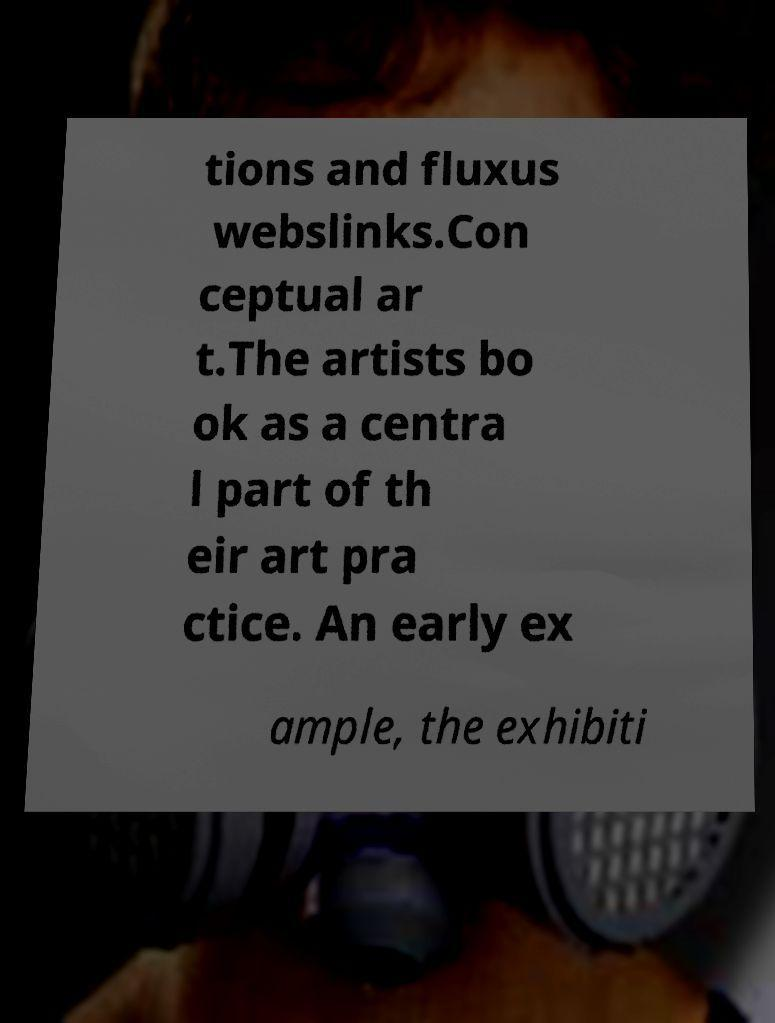Please identify and transcribe the text found in this image. tions and fluxus webslinks.Con ceptual ar t.The artists bo ok as a centra l part of th eir art pra ctice. An early ex ample, the exhibiti 